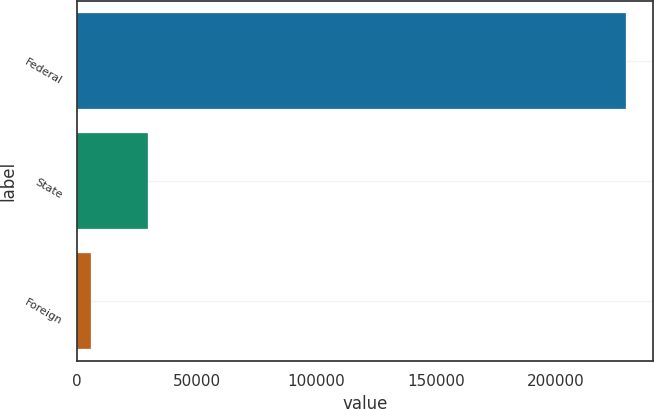Convert chart to OTSL. <chart><loc_0><loc_0><loc_500><loc_500><bar_chart><fcel>Federal<fcel>State<fcel>Foreign<nl><fcel>229135<fcel>29600<fcel>6097<nl></chart> 